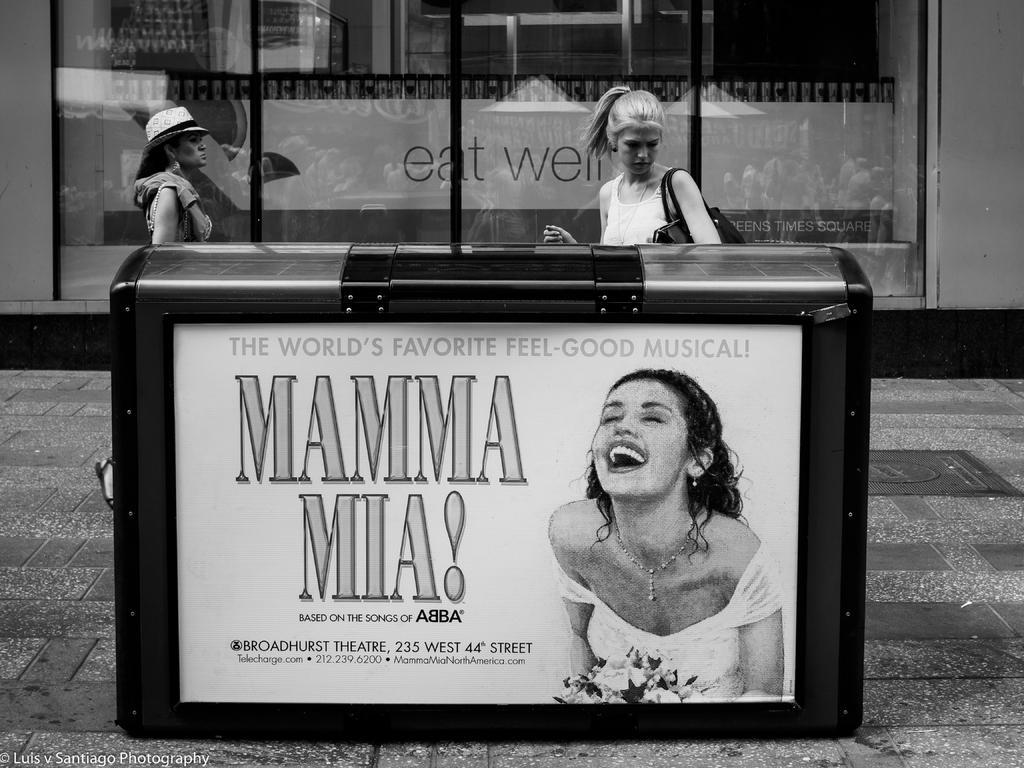How would you summarize this image in a sentence or two? In this black and white image, we can see a box contains picture of a person and some text. There are two persons wearing clothes in front of the glass door. 